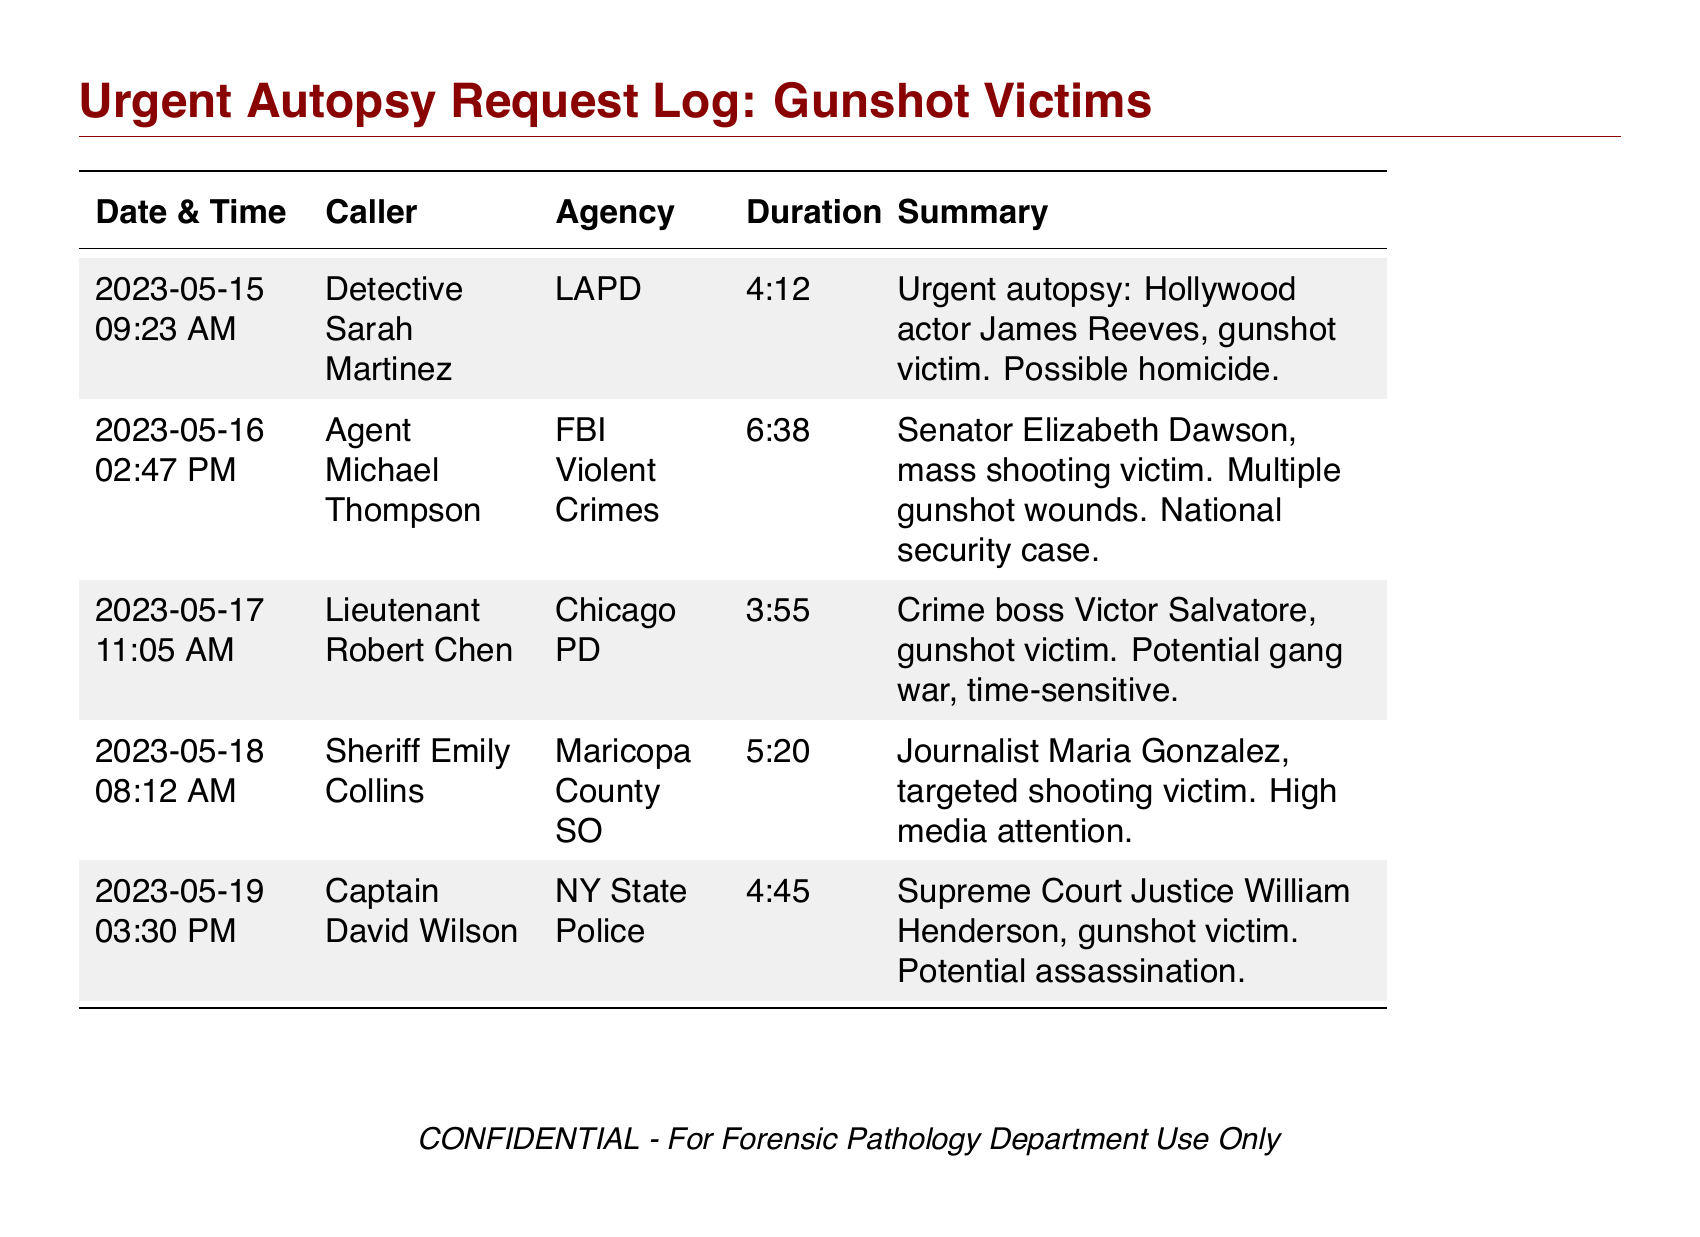what is the date of the urgent autopsy request for James Reeves? The date of the autopsy request for James Reeves is mentioned in the entry for that case.
Answer: 2023-05-15 who is the caller for the autopsy request involving a senator? The caller's name is specified in the entry for the senator's case.
Answer: Agent Michael Thompson what is the duration of the call from Lieutenant Robert Chen? The duration of the call is noted in the corresponding entry and indicates how long the call lasted.
Answer: 3:55 how many gunshot wounds did Senator Elizabeth Dawson have? The document states the nature of injuries for Senator Elizabeth Dawson's case.
Answer: Multiple gunshot wounds which agency requested the autopsy for the crime boss? The agency that made the request is clearly indicated in the related entry of the document.
Answer: Chicago PD which victim was involved in a targeted shooting and received high media attention? The document summarizes the details of the victims, specifying one who was the subject of media focus.
Answer: Journalist Maria Gonzalez what time did the call regarding Supreme Court Justice William Henderson occur? The precise time of the call is detailed in the entry for that specific case.
Answer: 03:30 PM who called regarding the gunshot victim James Reeves? The name of the call initiator for James Reeves is recorded in the document.
Answer: Detective Sarah Martinez how many total urgent autopsy requests are logged in this document? The document lists each request, allowing for a straightforward count of the entries.
Answer: 5 